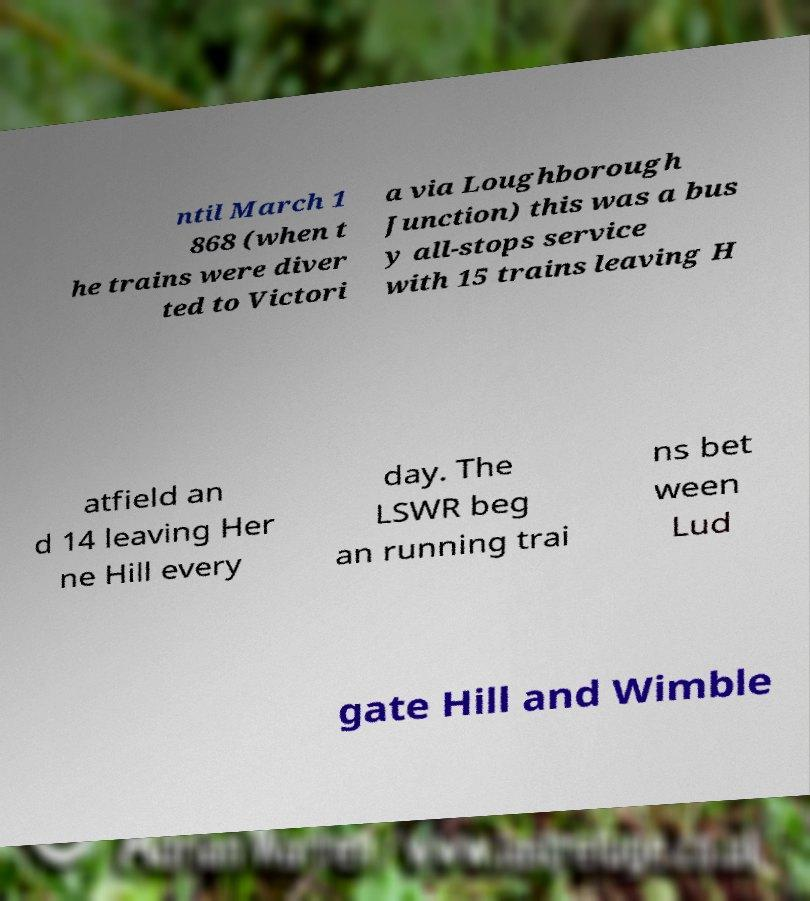Can you accurately transcribe the text from the provided image for me? ntil March 1 868 (when t he trains were diver ted to Victori a via Loughborough Junction) this was a bus y all-stops service with 15 trains leaving H atfield an d 14 leaving Her ne Hill every day. The LSWR beg an running trai ns bet ween Lud gate Hill and Wimble 